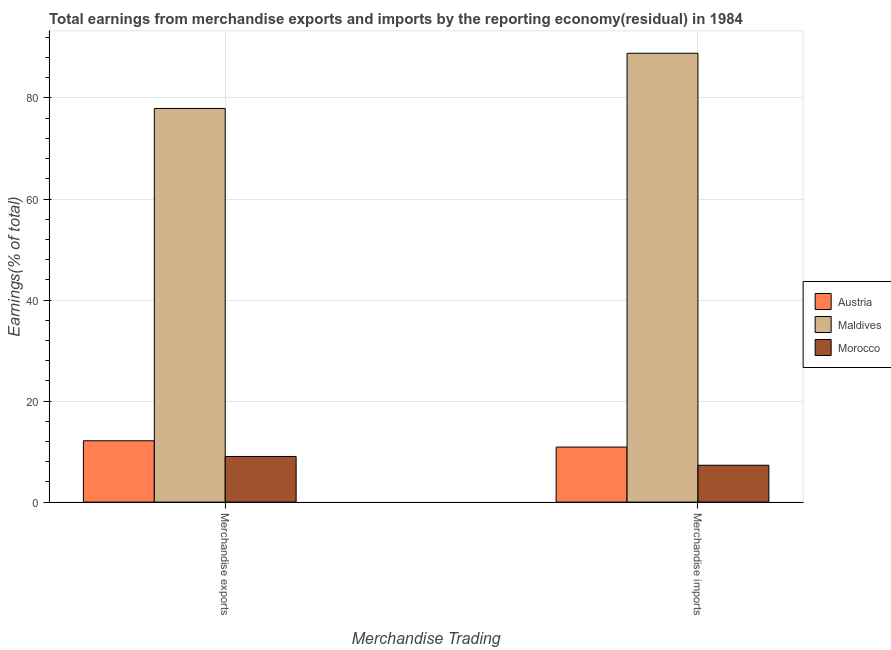How many groups of bars are there?
Make the answer very short. 2. Are the number of bars on each tick of the X-axis equal?
Provide a succinct answer. Yes. How many bars are there on the 2nd tick from the right?
Offer a very short reply. 3. What is the earnings from merchandise exports in Morocco?
Offer a very short reply. 9.04. Across all countries, what is the maximum earnings from merchandise imports?
Offer a terse response. 88.85. Across all countries, what is the minimum earnings from merchandise exports?
Offer a very short reply. 9.04. In which country was the earnings from merchandise exports maximum?
Your response must be concise. Maldives. In which country was the earnings from merchandise imports minimum?
Your response must be concise. Morocco. What is the total earnings from merchandise exports in the graph?
Provide a succinct answer. 99.1. What is the difference between the earnings from merchandise imports in Austria and that in Maldives?
Give a very brief answer. -77.95. What is the difference between the earnings from merchandise imports in Maldives and the earnings from merchandise exports in Austria?
Make the answer very short. 76.7. What is the average earnings from merchandise exports per country?
Offer a very short reply. 33.03. What is the difference between the earnings from merchandise imports and earnings from merchandise exports in Morocco?
Your response must be concise. -1.73. In how many countries, is the earnings from merchandise exports greater than 76 %?
Your answer should be compact. 1. What is the ratio of the earnings from merchandise exports in Austria to that in Morocco?
Offer a very short reply. 1.34. Is the earnings from merchandise exports in Austria less than that in Morocco?
Your answer should be very brief. No. In how many countries, is the earnings from merchandise imports greater than the average earnings from merchandise imports taken over all countries?
Keep it short and to the point. 1. What does the 3rd bar from the left in Merchandise exports represents?
Your answer should be compact. Morocco. What does the 3rd bar from the right in Merchandise exports represents?
Give a very brief answer. Austria. How many bars are there?
Provide a short and direct response. 6. Are all the bars in the graph horizontal?
Keep it short and to the point. No. How many countries are there in the graph?
Offer a very short reply. 3. Are the values on the major ticks of Y-axis written in scientific E-notation?
Keep it short and to the point. No. Does the graph contain grids?
Your answer should be compact. Yes. How are the legend labels stacked?
Your response must be concise. Vertical. What is the title of the graph?
Make the answer very short. Total earnings from merchandise exports and imports by the reporting economy(residual) in 1984. Does "Sub-Saharan Africa (developing only)" appear as one of the legend labels in the graph?
Ensure brevity in your answer.  No. What is the label or title of the X-axis?
Offer a terse response. Merchandise Trading. What is the label or title of the Y-axis?
Make the answer very short. Earnings(% of total). What is the Earnings(% of total) in Austria in Merchandise exports?
Your answer should be very brief. 12.14. What is the Earnings(% of total) of Maldives in Merchandise exports?
Offer a very short reply. 77.92. What is the Earnings(% of total) in Morocco in Merchandise exports?
Make the answer very short. 9.04. What is the Earnings(% of total) of Austria in Merchandise imports?
Offer a very short reply. 10.9. What is the Earnings(% of total) of Maldives in Merchandise imports?
Keep it short and to the point. 88.85. What is the Earnings(% of total) in Morocco in Merchandise imports?
Give a very brief answer. 7.3. Across all Merchandise Trading, what is the maximum Earnings(% of total) of Austria?
Your response must be concise. 12.14. Across all Merchandise Trading, what is the maximum Earnings(% of total) in Maldives?
Provide a succinct answer. 88.85. Across all Merchandise Trading, what is the maximum Earnings(% of total) of Morocco?
Give a very brief answer. 9.04. Across all Merchandise Trading, what is the minimum Earnings(% of total) of Austria?
Offer a terse response. 10.9. Across all Merchandise Trading, what is the minimum Earnings(% of total) in Maldives?
Ensure brevity in your answer.  77.92. Across all Merchandise Trading, what is the minimum Earnings(% of total) in Morocco?
Ensure brevity in your answer.  7.3. What is the total Earnings(% of total) of Austria in the graph?
Give a very brief answer. 23.04. What is the total Earnings(% of total) in Maldives in the graph?
Provide a short and direct response. 166.77. What is the total Earnings(% of total) in Morocco in the graph?
Make the answer very short. 16.34. What is the difference between the Earnings(% of total) in Austria in Merchandise exports and that in Merchandise imports?
Provide a succinct answer. 1.25. What is the difference between the Earnings(% of total) of Maldives in Merchandise exports and that in Merchandise imports?
Ensure brevity in your answer.  -10.92. What is the difference between the Earnings(% of total) in Morocco in Merchandise exports and that in Merchandise imports?
Your answer should be very brief. 1.73. What is the difference between the Earnings(% of total) of Austria in Merchandise exports and the Earnings(% of total) of Maldives in Merchandise imports?
Provide a short and direct response. -76.7. What is the difference between the Earnings(% of total) of Austria in Merchandise exports and the Earnings(% of total) of Morocco in Merchandise imports?
Offer a terse response. 4.84. What is the difference between the Earnings(% of total) of Maldives in Merchandise exports and the Earnings(% of total) of Morocco in Merchandise imports?
Give a very brief answer. 70.62. What is the average Earnings(% of total) of Austria per Merchandise Trading?
Ensure brevity in your answer.  11.52. What is the average Earnings(% of total) of Maldives per Merchandise Trading?
Your response must be concise. 83.39. What is the average Earnings(% of total) in Morocco per Merchandise Trading?
Offer a very short reply. 8.17. What is the difference between the Earnings(% of total) of Austria and Earnings(% of total) of Maldives in Merchandise exports?
Ensure brevity in your answer.  -65.78. What is the difference between the Earnings(% of total) in Austria and Earnings(% of total) in Morocco in Merchandise exports?
Provide a short and direct response. 3.11. What is the difference between the Earnings(% of total) of Maldives and Earnings(% of total) of Morocco in Merchandise exports?
Offer a terse response. 68.89. What is the difference between the Earnings(% of total) of Austria and Earnings(% of total) of Maldives in Merchandise imports?
Offer a very short reply. -77.95. What is the difference between the Earnings(% of total) in Austria and Earnings(% of total) in Morocco in Merchandise imports?
Offer a terse response. 3.6. What is the difference between the Earnings(% of total) in Maldives and Earnings(% of total) in Morocco in Merchandise imports?
Offer a very short reply. 81.55. What is the ratio of the Earnings(% of total) in Austria in Merchandise exports to that in Merchandise imports?
Your answer should be very brief. 1.11. What is the ratio of the Earnings(% of total) of Maldives in Merchandise exports to that in Merchandise imports?
Your answer should be very brief. 0.88. What is the ratio of the Earnings(% of total) of Morocco in Merchandise exports to that in Merchandise imports?
Provide a short and direct response. 1.24. What is the difference between the highest and the second highest Earnings(% of total) of Austria?
Offer a very short reply. 1.25. What is the difference between the highest and the second highest Earnings(% of total) in Maldives?
Make the answer very short. 10.92. What is the difference between the highest and the second highest Earnings(% of total) in Morocco?
Ensure brevity in your answer.  1.73. What is the difference between the highest and the lowest Earnings(% of total) of Austria?
Your response must be concise. 1.25. What is the difference between the highest and the lowest Earnings(% of total) of Maldives?
Give a very brief answer. 10.92. What is the difference between the highest and the lowest Earnings(% of total) in Morocco?
Offer a terse response. 1.73. 